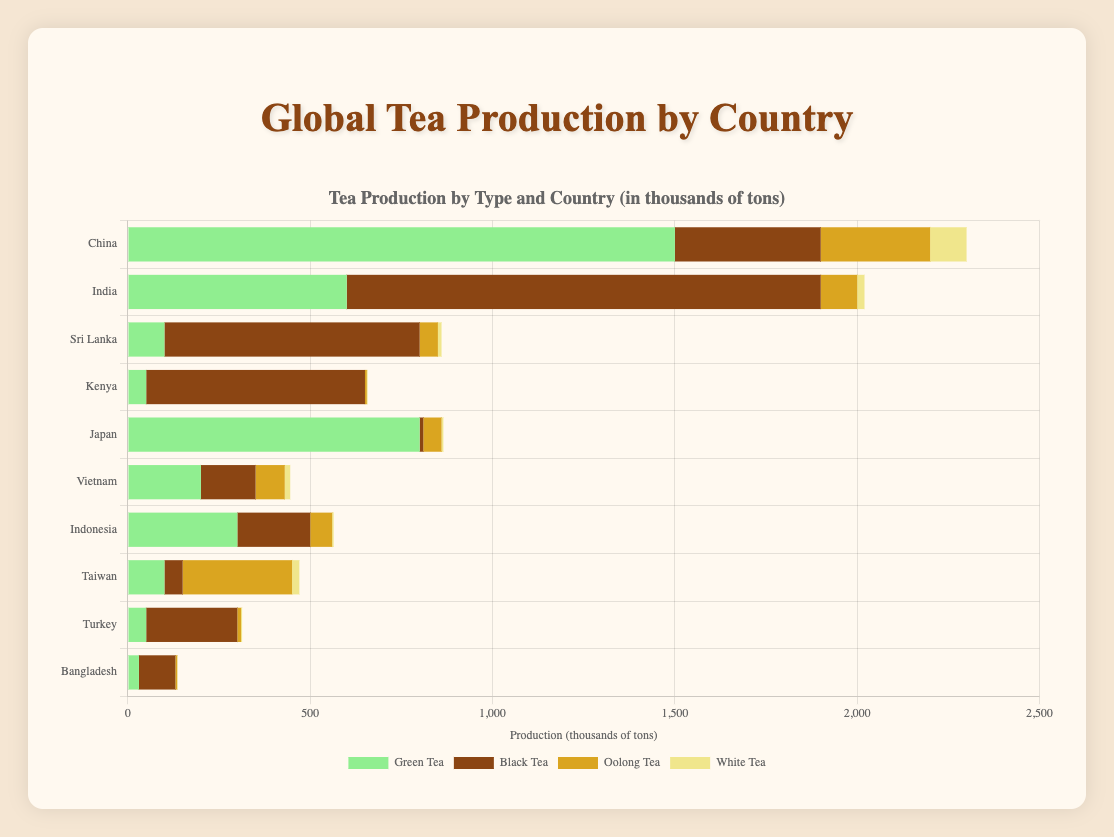What's the total production of tea in China? To find the total tea production in China, sum up the amounts of each type of tea: Green Tea (1500) + Black Tea (400) + Oolong Tea (300) + White Tea (100). Therefore, the total production is 2300 thousand tons.
Answer: 2300 Which country produces more Green Tea, China or Japan? Comparing the Green Tea production between China (1500) and Japan (800), we can see that China produces more Green Tea.
Answer: China What is the difference in Black Tea production between India and Sri Lanka? To find the difference, subtract Sri Lanka's Black Tea production (700) from India's (1300). Therefore, the difference is 600 thousand tons.
Answer: 600 Which country has the most diversified tea production in terms of tea types? By examining the bar chart, China depicts a significant amount in all four categories, hinting at diversified production.
Answer: China How many times more Black Tea does India produce compared to Japan? India produces 1,300 thousand tons, while Japan produces 10. Dividing these two gives 130 times.
Answer: 130 What is the combined production of White Tea in Taiwan and China? Adding White Tea production in Taiwan (20) and China (100), the combined total is 120 thousand tons.
Answer: 120 Which country contributes the most to Oolong Tea production? By comparing the heights of the Oolong Tea bars for all countries, Taiwan, with the highest Oolong Tea bar, produces the most.
Answer: Taiwan Among the listed countries, which one has the highest total production of Black Tea? India’s bar for Black Tea is significantly taller than the others, indicating the highest production at 1300 thousand tons.
Answer: India How does Sri Lanka's total tea production compare to Vietnam's total tea production? Summing Sri Lanka's total (100 + 700 + 50 + 10 = 860) and Vietnam's (200 + 150 + 80 + 15 = 445), Sri Lanka produces more.
Answer: Sri Lanka What is the average production of Oolong Tea across all countries? Sum the Oolong Tea production (300 + 100 + 50 + 5 + 50 + 80 + 60 + 300 + 10 + 5 = 960) and divide by the number of countries (10). The average is 960 / 10 = 96 thousand tons.
Answer: 96 